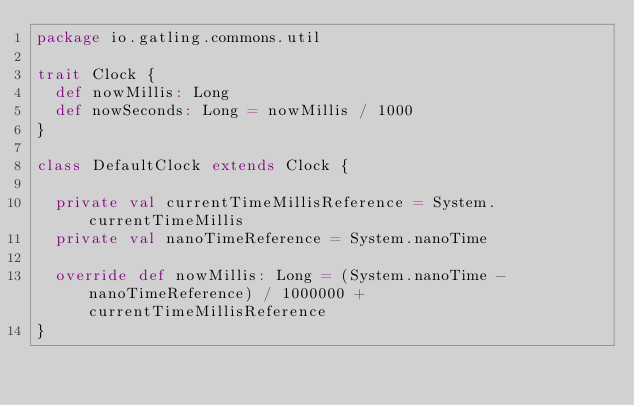Convert code to text. <code><loc_0><loc_0><loc_500><loc_500><_Scala_>package io.gatling.commons.util

trait Clock {
  def nowMillis: Long
  def nowSeconds: Long = nowMillis / 1000
}

class DefaultClock extends Clock {

  private val currentTimeMillisReference = System.currentTimeMillis
  private val nanoTimeReference = System.nanoTime

  override def nowMillis: Long = (System.nanoTime - nanoTimeReference) / 1000000 + currentTimeMillisReference
}
</code> 